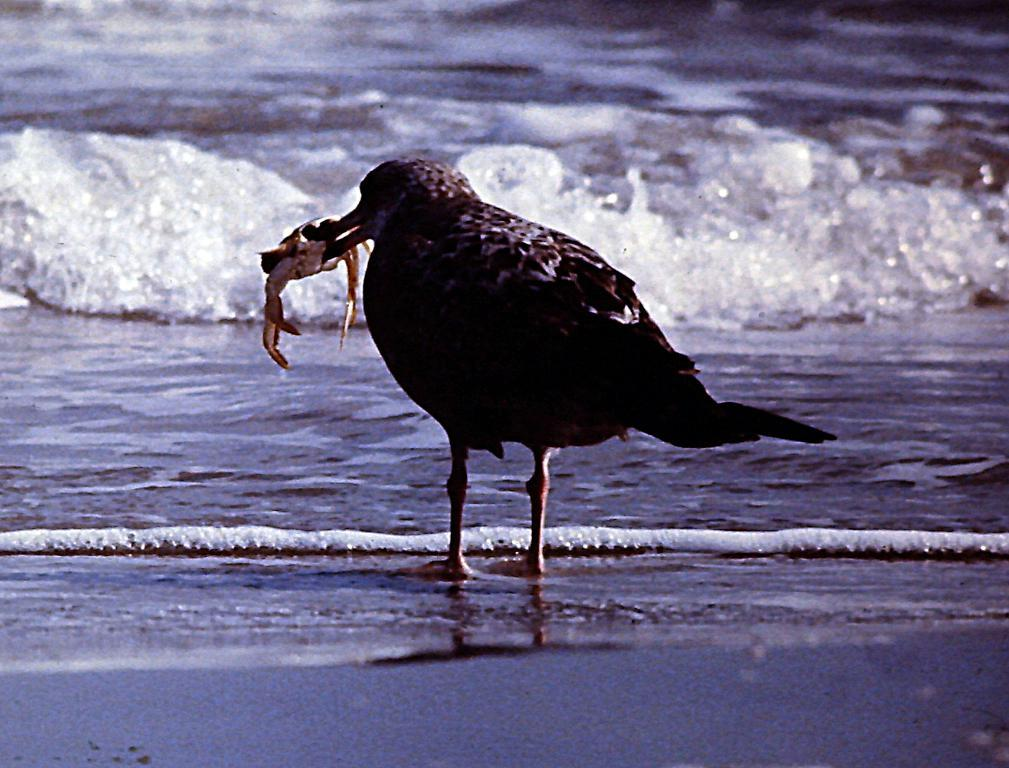What is the main subject in the center of the picture? There is a bird in the center of the picture. What is the bird holding in its claws? The bird is holding a crab. What type of environment can be seen in the background of the image? There is a water body in the background of the image. What type of surface is visible at the bottom of the image? The bottom of the image appears to be sand. What is the name of the farm where the bird and crab live? There is no farm mentioned or depicted in the image, and therefore no name can be provided. 